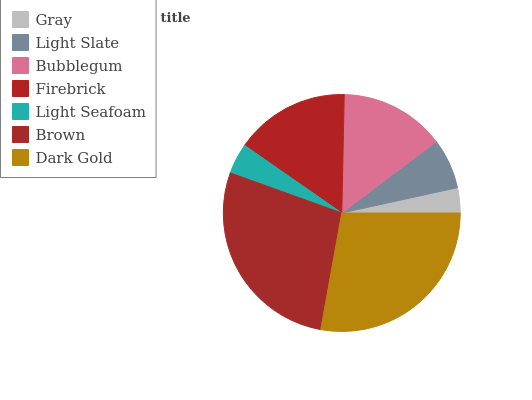Is Gray the minimum?
Answer yes or no. Yes. Is Dark Gold the maximum?
Answer yes or no. Yes. Is Light Slate the minimum?
Answer yes or no. No. Is Light Slate the maximum?
Answer yes or no. No. Is Light Slate greater than Gray?
Answer yes or no. Yes. Is Gray less than Light Slate?
Answer yes or no. Yes. Is Gray greater than Light Slate?
Answer yes or no. No. Is Light Slate less than Gray?
Answer yes or no. No. Is Bubblegum the high median?
Answer yes or no. Yes. Is Bubblegum the low median?
Answer yes or no. Yes. Is Dark Gold the high median?
Answer yes or no. No. Is Light Seafoam the low median?
Answer yes or no. No. 